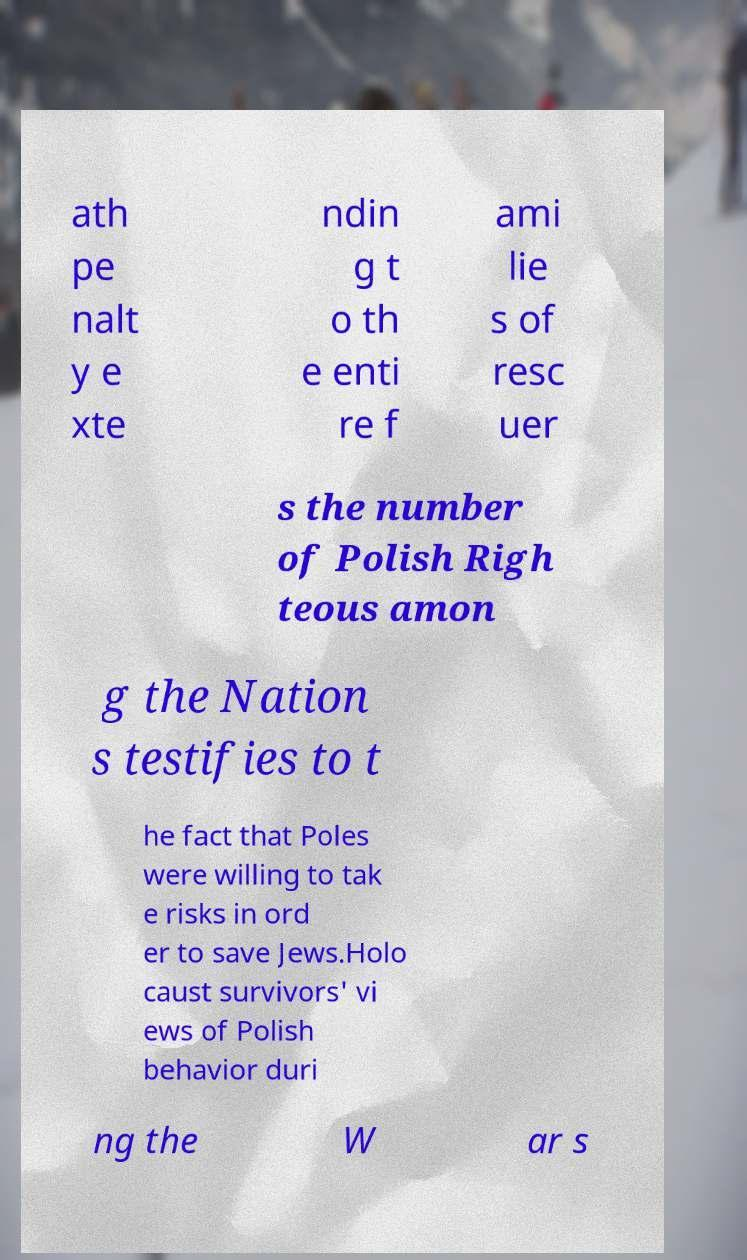Could you extract and type out the text from this image? ath pe nalt y e xte ndin g t o th e enti re f ami lie s of resc uer s the number of Polish Righ teous amon g the Nation s testifies to t he fact that Poles were willing to tak e risks in ord er to save Jews.Holo caust survivors' vi ews of Polish behavior duri ng the W ar s 